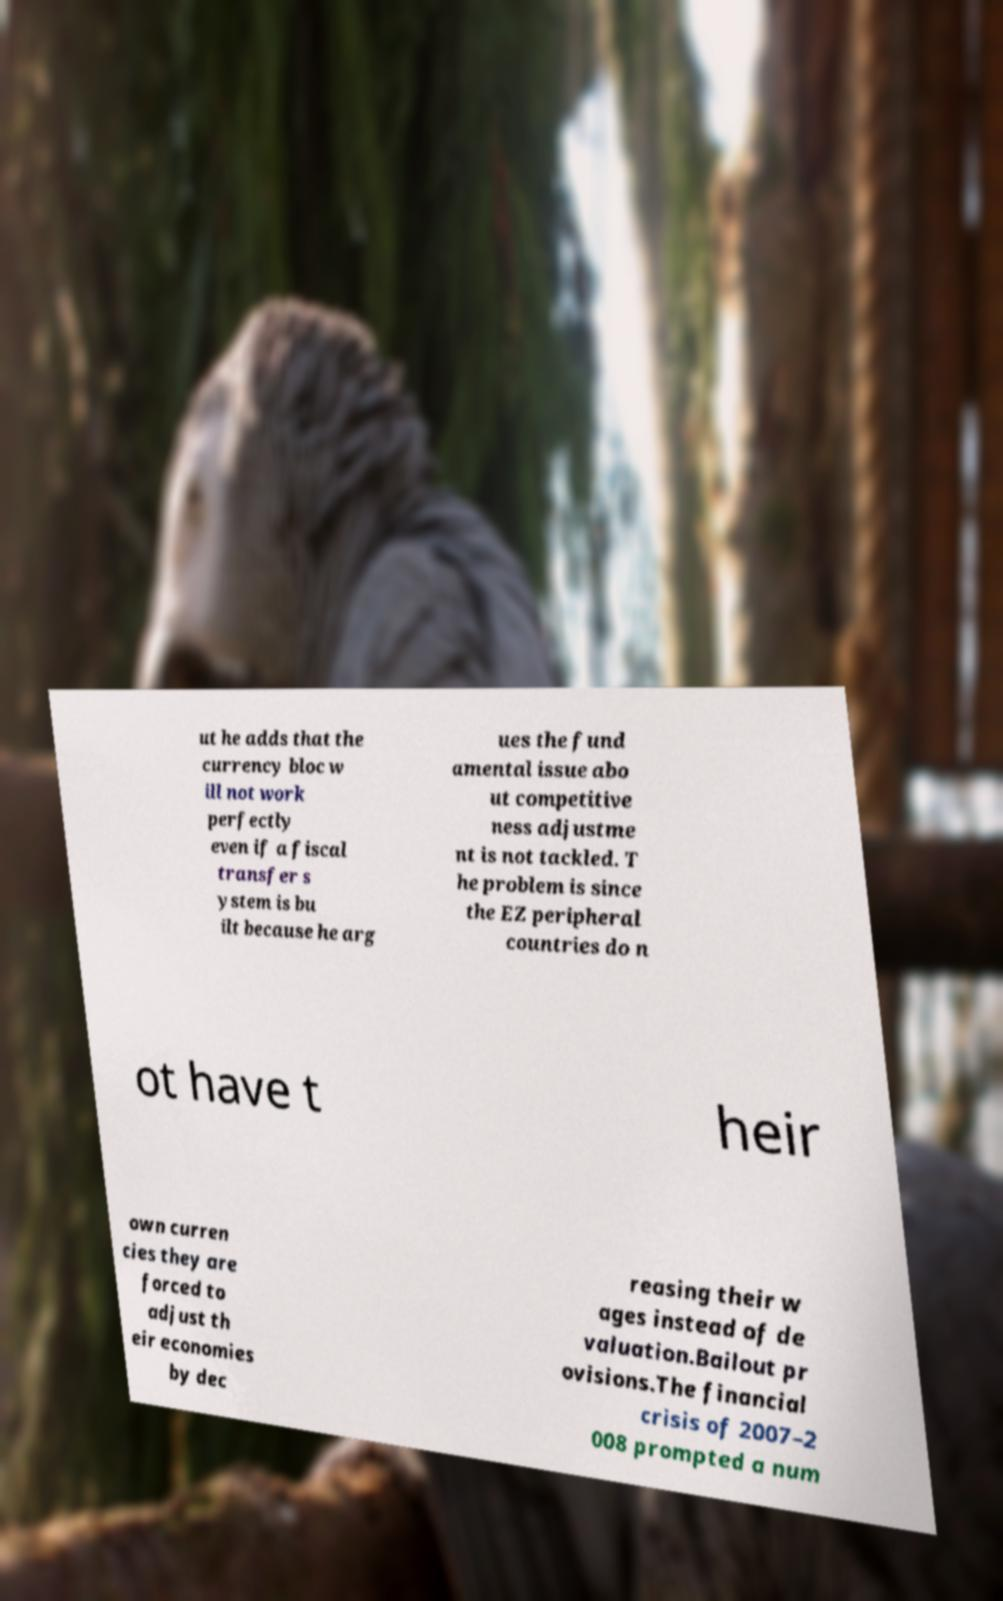Can you accurately transcribe the text from the provided image for me? ut he adds that the currency bloc w ill not work perfectly even if a fiscal transfer s ystem is bu ilt because he arg ues the fund amental issue abo ut competitive ness adjustme nt is not tackled. T he problem is since the EZ peripheral countries do n ot have t heir own curren cies they are forced to adjust th eir economies by dec reasing their w ages instead of de valuation.Bailout pr ovisions.The financial crisis of 2007–2 008 prompted a num 